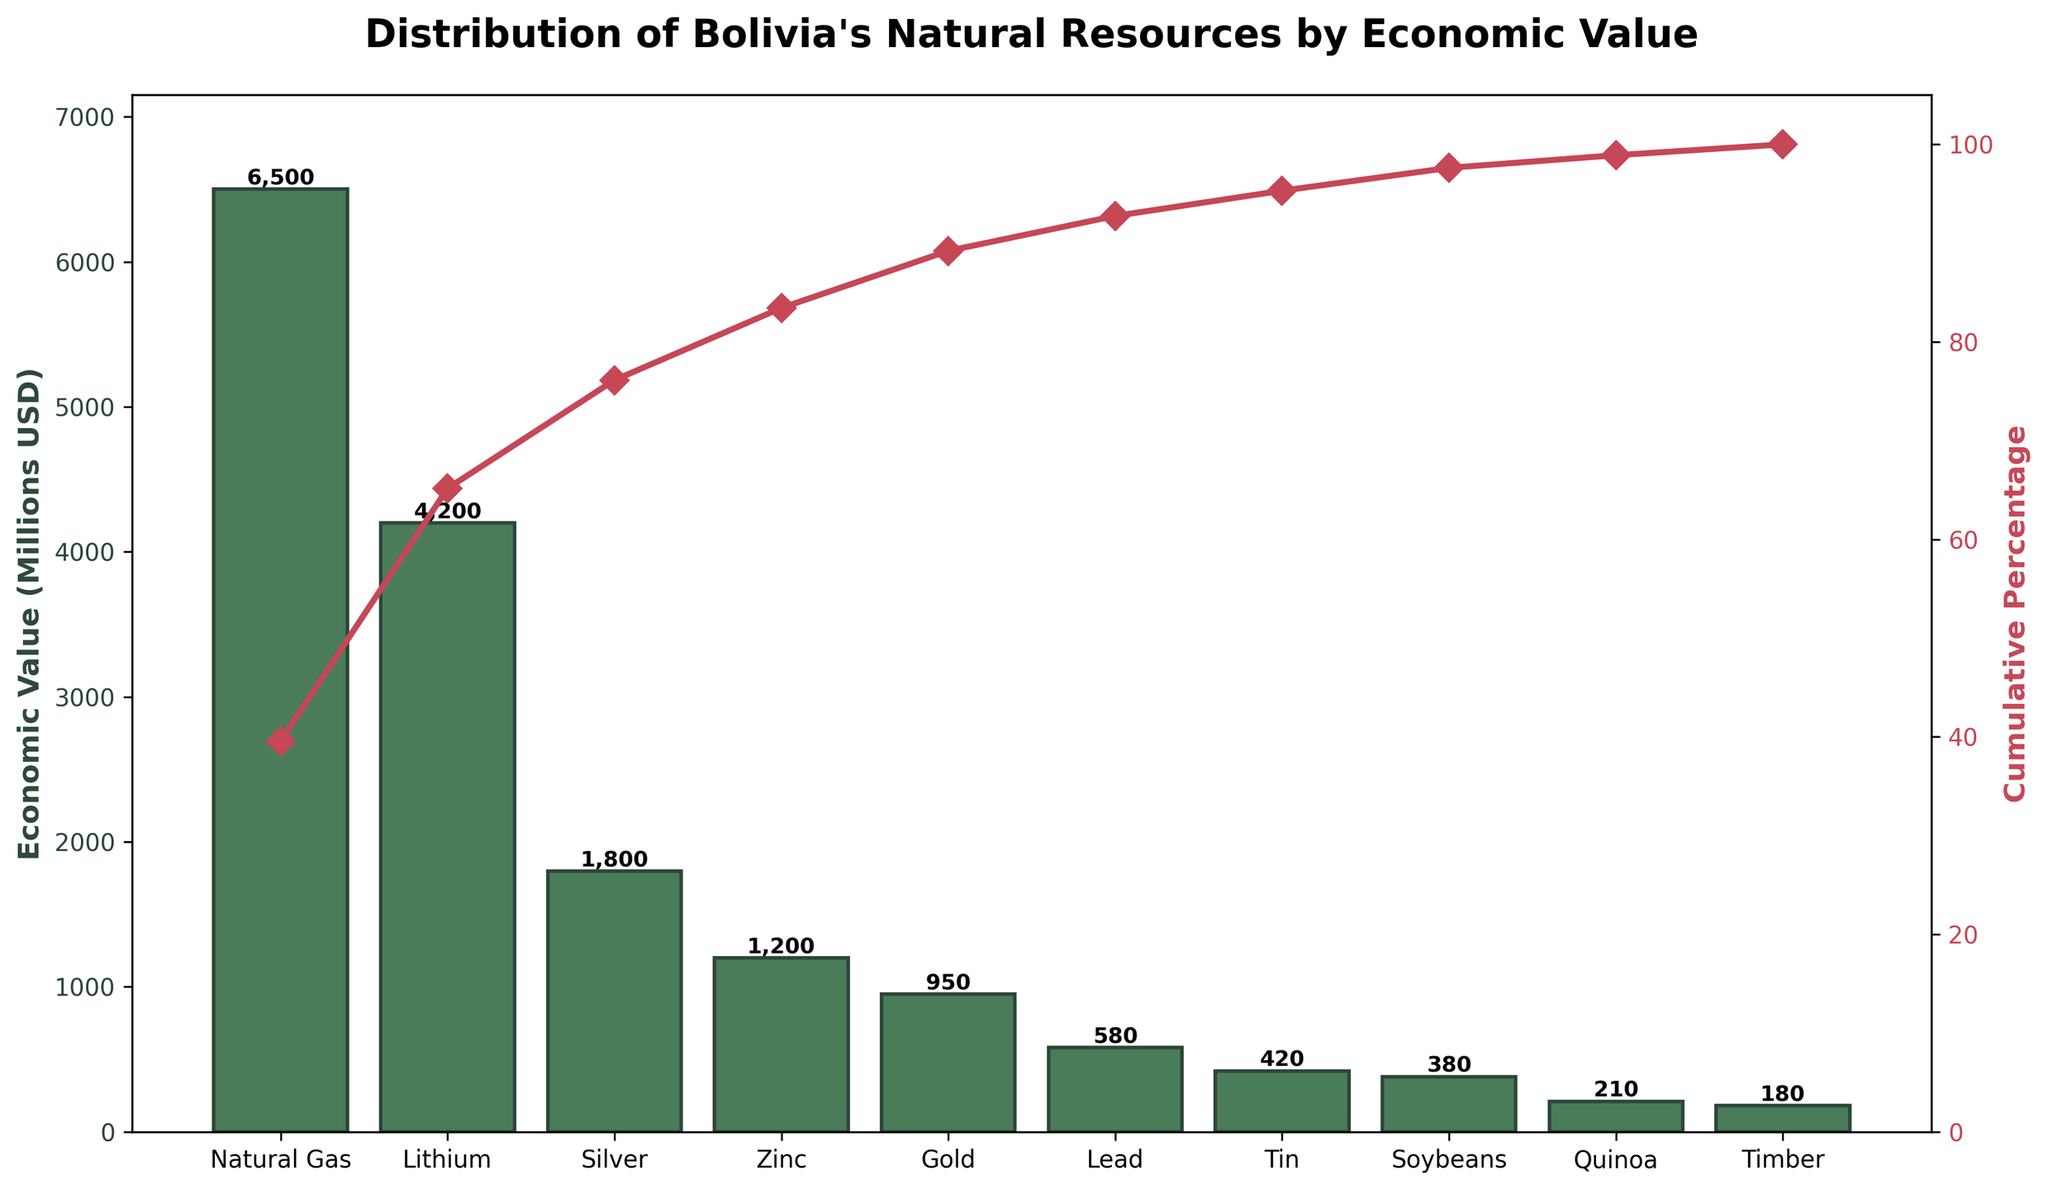what is the title of the chart? The title is usually placed at the top of the chart. In this case, the title reads "Distribution of Bolivia's Natural Resources by Economic Value".
Answer: Distribution of Bolivia's Natural Resources by Economic Value what does the left y-axis represent? The left y-axis represents the economic value of different natural resources in millions of USD.
Answer: Economic Value (Millions USD) what does the right y-axis represent? The right y-axis represents the cumulative percentage of economic values of natural resources.
Answer: Cumulative Percentage how many natural resources are represented on the x-axis? By counting the bars on the x-axis, we can see that there are 10 natural resources represented.
Answer: 10 which resource has the highest economic value? The bars in a Pareto chart are arranged in descending order. Therefore, the first bar represents the resource with the highest economic value, which is Natural Gas.
Answer: Natural Gas what is the economic value of zinc? Locate the bar corresponding to Zinc on the x-axis and read its height value on the left y-axis. Zinc has an economic value of 1,200 million USD.
Answer: 1,200 million USD which resources contribute to over 50% of the cumulative percentage? To determine this, we follow the cumulative percentage line from the left until it surpasses 50%, then check all resources before this point. Natural Gas and Lithium together exceed 50%.
Answer: Natural Gas, Lithium what is the cumulative percentage of the top three resources? We locate the cumulative percentage value after the third resource (Silver) by following the dashed line upwards. The value is approximately 82%.
Answer: 82% which resource has a higher economic value: gold or lead? By comparing the heights of the bars representing Gold and Lead, we see that Gold has a higher economic value (950 million USD) than Lead (580 million USD).
Answer: Gold how many resources have an economic value below 500 million USD? By inspecting the bars on the chart, we notice Tin, Soybeans, Quinoa, and Timber have economic values below 500 million USD. These add up to 4 resources.
Answer: 4 